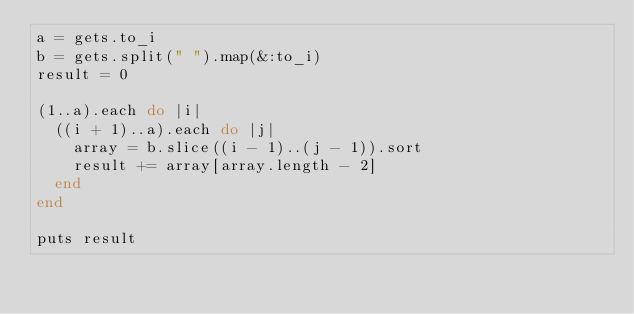<code> <loc_0><loc_0><loc_500><loc_500><_Ruby_>a = gets.to_i
b = gets.split(" ").map(&:to_i)
result = 0

(1..a).each do |i|
  ((i + 1)..a).each do |j|
    array = b.slice((i - 1)..(j - 1)).sort
    result += array[array.length - 2]
  end
end

puts result</code> 